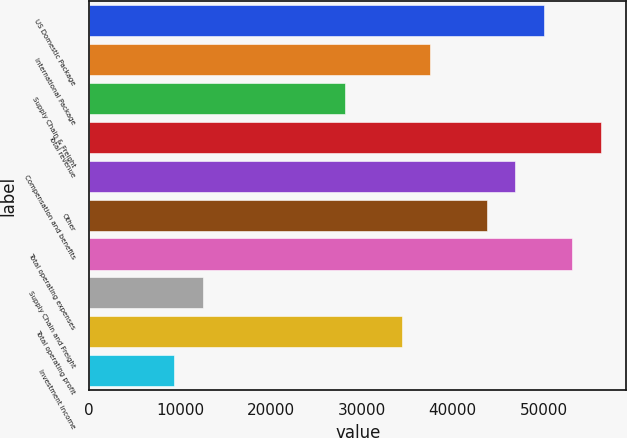<chart> <loc_0><loc_0><loc_500><loc_500><bar_chart><fcel>US Domestic Package<fcel>International Package<fcel>Supply Chain & Freight<fcel>Total revenue<fcel>Compensation and benefits<fcel>Other<fcel>Total operating expenses<fcel>Supply Chain and Freight<fcel>Total operating profit<fcel>Investment income<nl><fcel>50034.7<fcel>37526.2<fcel>28144.8<fcel>56288.9<fcel>46907.6<fcel>43780.4<fcel>53161.8<fcel>12509.2<fcel>34399.1<fcel>9382.12<nl></chart> 